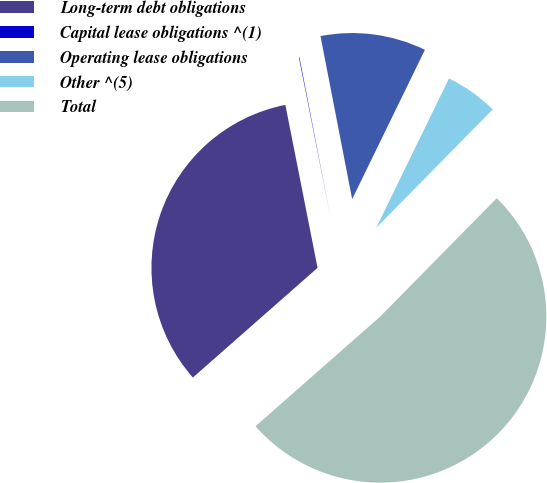Convert chart. <chart><loc_0><loc_0><loc_500><loc_500><pie_chart><fcel>Long-term debt obligations<fcel>Capital lease obligations ^(1)<fcel>Operating lease obligations<fcel>Other ^(5)<fcel>Total<nl><fcel>33.38%<fcel>0.05%<fcel>10.27%<fcel>5.16%<fcel>51.14%<nl></chart> 